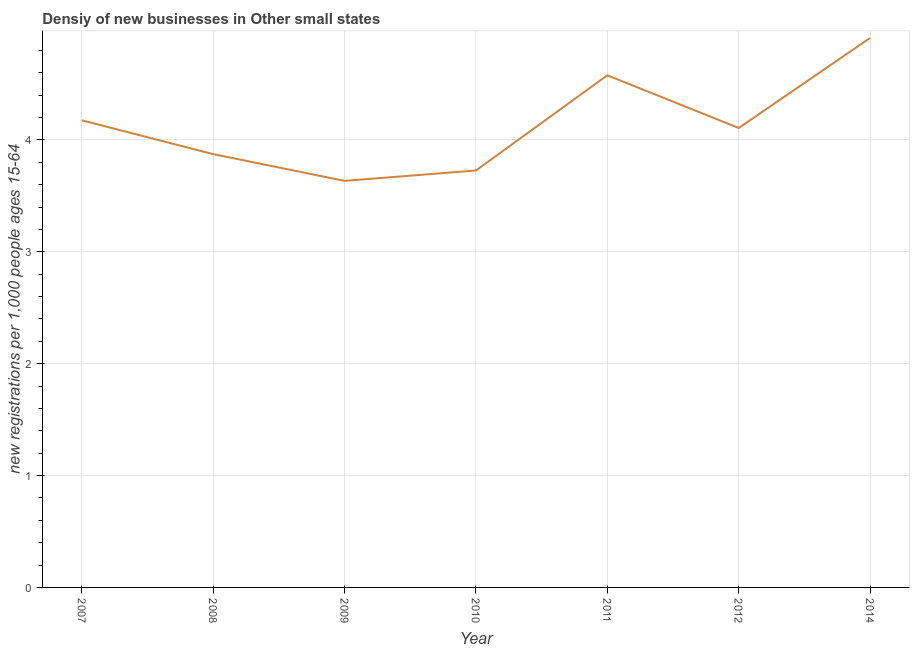What is the density of new business in 2011?
Your answer should be compact. 4.58. Across all years, what is the maximum density of new business?
Provide a short and direct response. 4.91. Across all years, what is the minimum density of new business?
Your response must be concise. 3.63. What is the sum of the density of new business?
Offer a very short reply. 29.01. What is the difference between the density of new business in 2007 and 2014?
Offer a terse response. -0.74. What is the average density of new business per year?
Provide a succinct answer. 4.14. What is the median density of new business?
Give a very brief answer. 4.11. Do a majority of the years between 2010 and 2007 (inclusive) have density of new business greater than 1 ?
Provide a succinct answer. Yes. What is the ratio of the density of new business in 2011 to that in 2012?
Your answer should be very brief. 1.11. Is the density of new business in 2008 less than that in 2011?
Ensure brevity in your answer.  Yes. Is the difference between the density of new business in 2009 and 2011 greater than the difference between any two years?
Make the answer very short. No. What is the difference between the highest and the second highest density of new business?
Give a very brief answer. 0.33. Is the sum of the density of new business in 2007 and 2008 greater than the maximum density of new business across all years?
Offer a very short reply. Yes. What is the difference between the highest and the lowest density of new business?
Give a very brief answer. 1.28. Does the density of new business monotonically increase over the years?
Your answer should be compact. No. How many lines are there?
Your answer should be very brief. 1. Are the values on the major ticks of Y-axis written in scientific E-notation?
Offer a terse response. No. What is the title of the graph?
Keep it short and to the point. Densiy of new businesses in Other small states. What is the label or title of the Y-axis?
Keep it short and to the point. New registrations per 1,0 people ages 15-64. What is the new registrations per 1,000 people ages 15-64 of 2007?
Provide a succinct answer. 4.18. What is the new registrations per 1,000 people ages 15-64 of 2008?
Make the answer very short. 3.87. What is the new registrations per 1,000 people ages 15-64 in 2009?
Provide a succinct answer. 3.63. What is the new registrations per 1,000 people ages 15-64 of 2010?
Your response must be concise. 3.73. What is the new registrations per 1,000 people ages 15-64 of 2011?
Offer a very short reply. 4.58. What is the new registrations per 1,000 people ages 15-64 in 2012?
Provide a short and direct response. 4.11. What is the new registrations per 1,000 people ages 15-64 of 2014?
Ensure brevity in your answer.  4.91. What is the difference between the new registrations per 1,000 people ages 15-64 in 2007 and 2008?
Give a very brief answer. 0.3. What is the difference between the new registrations per 1,000 people ages 15-64 in 2007 and 2009?
Your answer should be very brief. 0.54. What is the difference between the new registrations per 1,000 people ages 15-64 in 2007 and 2010?
Your answer should be very brief. 0.45. What is the difference between the new registrations per 1,000 people ages 15-64 in 2007 and 2011?
Your answer should be compact. -0.4. What is the difference between the new registrations per 1,000 people ages 15-64 in 2007 and 2012?
Provide a succinct answer. 0.07. What is the difference between the new registrations per 1,000 people ages 15-64 in 2007 and 2014?
Offer a terse response. -0.74. What is the difference between the new registrations per 1,000 people ages 15-64 in 2008 and 2009?
Your answer should be very brief. 0.24. What is the difference between the new registrations per 1,000 people ages 15-64 in 2008 and 2010?
Keep it short and to the point. 0.15. What is the difference between the new registrations per 1,000 people ages 15-64 in 2008 and 2011?
Ensure brevity in your answer.  -0.7. What is the difference between the new registrations per 1,000 people ages 15-64 in 2008 and 2012?
Your answer should be very brief. -0.23. What is the difference between the new registrations per 1,000 people ages 15-64 in 2008 and 2014?
Your answer should be very brief. -1.04. What is the difference between the new registrations per 1,000 people ages 15-64 in 2009 and 2010?
Your answer should be very brief. -0.09. What is the difference between the new registrations per 1,000 people ages 15-64 in 2009 and 2011?
Ensure brevity in your answer.  -0.94. What is the difference between the new registrations per 1,000 people ages 15-64 in 2009 and 2012?
Your answer should be very brief. -0.47. What is the difference between the new registrations per 1,000 people ages 15-64 in 2009 and 2014?
Provide a succinct answer. -1.28. What is the difference between the new registrations per 1,000 people ages 15-64 in 2010 and 2011?
Your answer should be compact. -0.85. What is the difference between the new registrations per 1,000 people ages 15-64 in 2010 and 2012?
Offer a terse response. -0.38. What is the difference between the new registrations per 1,000 people ages 15-64 in 2010 and 2014?
Your answer should be very brief. -1.18. What is the difference between the new registrations per 1,000 people ages 15-64 in 2011 and 2012?
Provide a short and direct response. 0.47. What is the difference between the new registrations per 1,000 people ages 15-64 in 2011 and 2014?
Your response must be concise. -0.33. What is the difference between the new registrations per 1,000 people ages 15-64 in 2012 and 2014?
Offer a very short reply. -0.8. What is the ratio of the new registrations per 1,000 people ages 15-64 in 2007 to that in 2008?
Your response must be concise. 1.08. What is the ratio of the new registrations per 1,000 people ages 15-64 in 2007 to that in 2009?
Give a very brief answer. 1.15. What is the ratio of the new registrations per 1,000 people ages 15-64 in 2007 to that in 2010?
Your answer should be very brief. 1.12. What is the ratio of the new registrations per 1,000 people ages 15-64 in 2007 to that in 2011?
Keep it short and to the point. 0.91. What is the ratio of the new registrations per 1,000 people ages 15-64 in 2008 to that in 2009?
Give a very brief answer. 1.07. What is the ratio of the new registrations per 1,000 people ages 15-64 in 2008 to that in 2010?
Give a very brief answer. 1.04. What is the ratio of the new registrations per 1,000 people ages 15-64 in 2008 to that in 2011?
Make the answer very short. 0.85. What is the ratio of the new registrations per 1,000 people ages 15-64 in 2008 to that in 2012?
Your answer should be very brief. 0.94. What is the ratio of the new registrations per 1,000 people ages 15-64 in 2008 to that in 2014?
Make the answer very short. 0.79. What is the ratio of the new registrations per 1,000 people ages 15-64 in 2009 to that in 2011?
Give a very brief answer. 0.79. What is the ratio of the new registrations per 1,000 people ages 15-64 in 2009 to that in 2012?
Make the answer very short. 0.89. What is the ratio of the new registrations per 1,000 people ages 15-64 in 2009 to that in 2014?
Offer a terse response. 0.74. What is the ratio of the new registrations per 1,000 people ages 15-64 in 2010 to that in 2011?
Keep it short and to the point. 0.81. What is the ratio of the new registrations per 1,000 people ages 15-64 in 2010 to that in 2012?
Keep it short and to the point. 0.91. What is the ratio of the new registrations per 1,000 people ages 15-64 in 2010 to that in 2014?
Provide a succinct answer. 0.76. What is the ratio of the new registrations per 1,000 people ages 15-64 in 2011 to that in 2012?
Provide a short and direct response. 1.11. What is the ratio of the new registrations per 1,000 people ages 15-64 in 2011 to that in 2014?
Provide a short and direct response. 0.93. What is the ratio of the new registrations per 1,000 people ages 15-64 in 2012 to that in 2014?
Give a very brief answer. 0.84. 